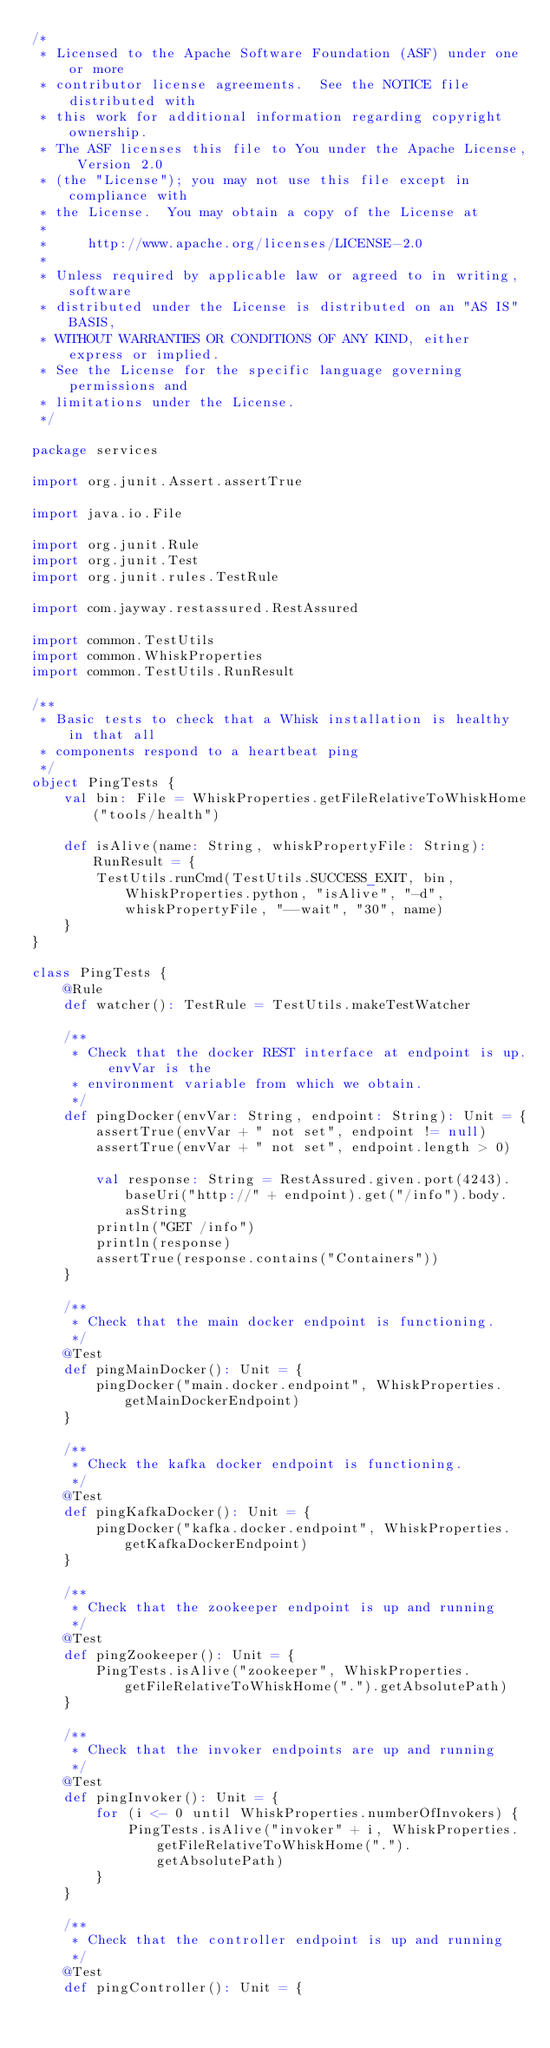Convert code to text. <code><loc_0><loc_0><loc_500><loc_500><_Scala_>/*
 * Licensed to the Apache Software Foundation (ASF) under one or more
 * contributor license agreements.  See the NOTICE file distributed with
 * this work for additional information regarding copyright ownership.
 * The ASF licenses this file to You under the Apache License, Version 2.0
 * (the "License"); you may not use this file except in compliance with
 * the License.  You may obtain a copy of the License at
 *
 *     http://www.apache.org/licenses/LICENSE-2.0
 *
 * Unless required by applicable law or agreed to in writing, software
 * distributed under the License is distributed on an "AS IS" BASIS,
 * WITHOUT WARRANTIES OR CONDITIONS OF ANY KIND, either express or implied.
 * See the License for the specific language governing permissions and
 * limitations under the License.
 */

package services

import org.junit.Assert.assertTrue

import java.io.File

import org.junit.Rule
import org.junit.Test
import org.junit.rules.TestRule

import com.jayway.restassured.RestAssured

import common.TestUtils
import common.WhiskProperties
import common.TestUtils.RunResult

/**
 * Basic tests to check that a Whisk installation is healthy in that all
 * components respond to a heartbeat ping
 */
object PingTests {
    val bin: File = WhiskProperties.getFileRelativeToWhiskHome("tools/health")

    def isAlive(name: String, whiskPropertyFile: String): RunResult = {
        TestUtils.runCmd(TestUtils.SUCCESS_EXIT, bin, WhiskProperties.python, "isAlive", "-d", whiskPropertyFile, "--wait", "30", name)
    }
}

class PingTests {
    @Rule
    def watcher(): TestRule = TestUtils.makeTestWatcher

    /**
     * Check that the docker REST interface at endpoint is up. envVar is the
     * environment variable from which we obtain.
     */
    def pingDocker(envVar: String, endpoint: String): Unit = {
        assertTrue(envVar + " not set", endpoint != null)
        assertTrue(envVar + " not set", endpoint.length > 0)

        val response: String = RestAssured.given.port(4243).baseUri("http://" + endpoint).get("/info").body.asString
        println("GET /info")
        println(response)
        assertTrue(response.contains("Containers"))
    }

    /**
     * Check that the main docker endpoint is functioning.
     */
    @Test
    def pingMainDocker(): Unit = {
        pingDocker("main.docker.endpoint", WhiskProperties.getMainDockerEndpoint)
    }

    /**
     * Check the kafka docker endpoint is functioning.
     */
    @Test
    def pingKafkaDocker(): Unit = {
        pingDocker("kafka.docker.endpoint", WhiskProperties.getKafkaDockerEndpoint)
    }

    /**
     * Check that the zookeeper endpoint is up and running
     */
    @Test
    def pingZookeeper(): Unit = {
        PingTests.isAlive("zookeeper", WhiskProperties.getFileRelativeToWhiskHome(".").getAbsolutePath)
    }

    /**
     * Check that the invoker endpoints are up and running
     */
    @Test
    def pingInvoker(): Unit = {
        for (i <- 0 until WhiskProperties.numberOfInvokers) {
            PingTests.isAlive("invoker" + i, WhiskProperties.getFileRelativeToWhiskHome(".").getAbsolutePath)
        }
    }

    /**
     * Check that the controller endpoint is up and running
     */
    @Test
    def pingController(): Unit = {</code> 